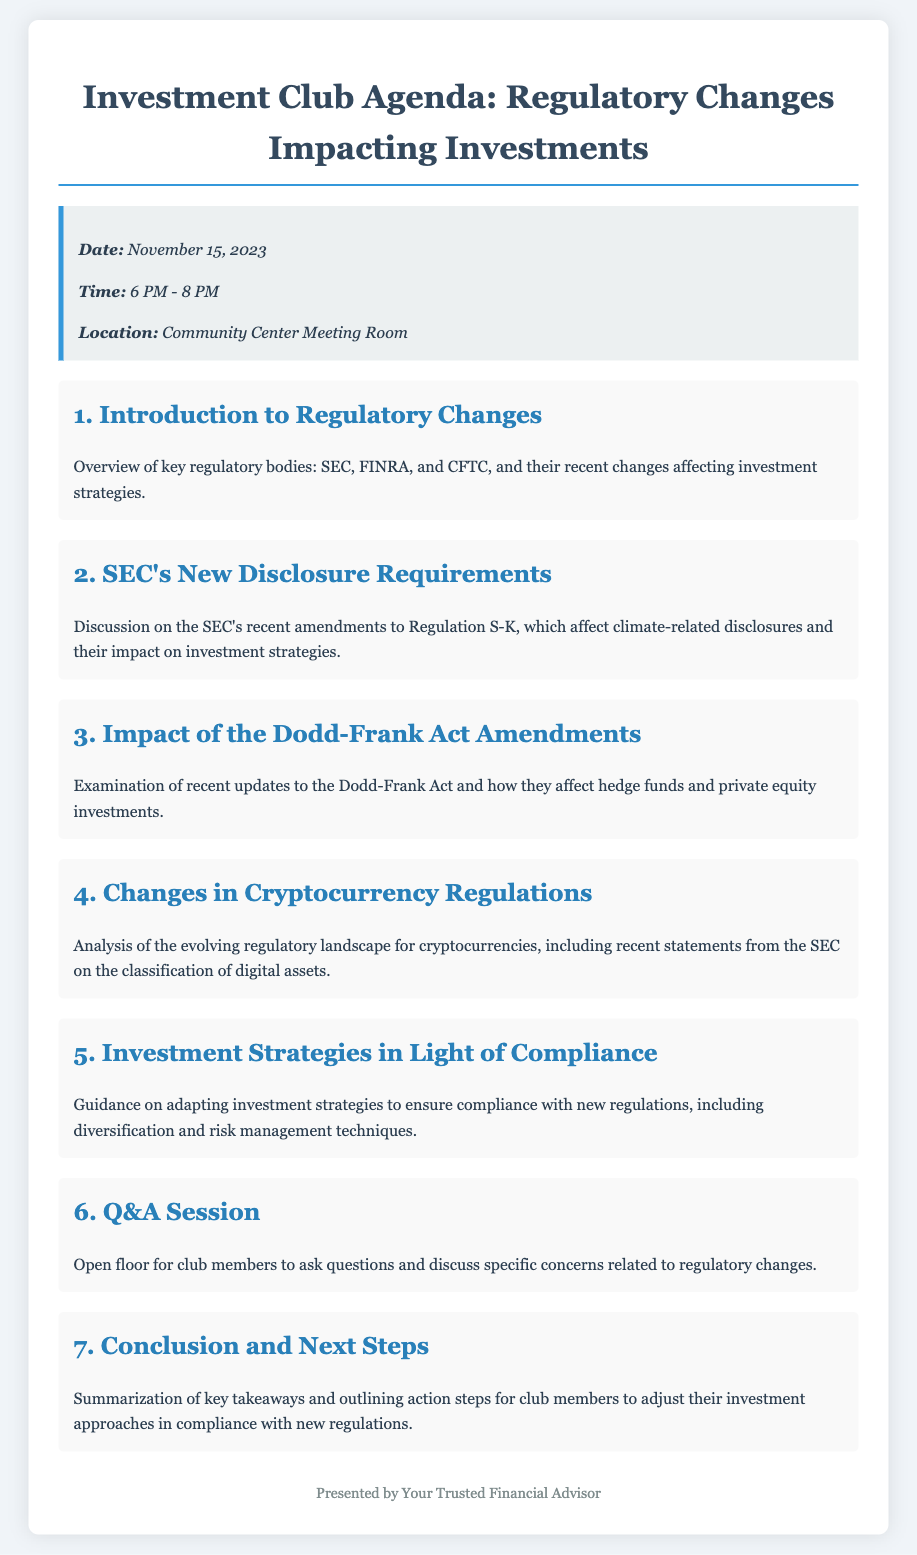What is the date of the event? The date of the event is specified in the event details section, which is November 15, 2023.
Answer: November 15, 2023 What is the time of the meeting? The time is indicated alongside the date in the event details, which is from 6 PM to 8 PM.
Answer: 6 PM - 8 PM Who are the key regulatory bodies mentioned? The agenda introduces three key regulatory bodies affecting investment strategies, which are the SEC, FINRA, and CFTC.
Answer: SEC, FINRA, CFTC What does the SEC's recent amendment affect? The description of the SEC's new disclosure requirements notes that the amendment concerns climate-related disclosures.
Answer: Climate-related disclosures Which act's amendments are discussed in the agenda? The agenda specifically mentions the Dodd-Frank Act and its recent updates affecting hedge funds and private equity.
Answer: Dodd-Frank Act What is one strategy suggested for compliance? The agenda item on adapting investment strategies mentions that diversification can be a strategy for compliance with new regulations.
Answer: Diversification How many main agenda items are listed? The total number of agenda items listed in the document adds up to seven significant topics for discussion.
Answer: Seven What session allows for member questions? The Q&A session section provides an opportunity for club members to ask questions and discuss regulatory concerns.
Answer: Q&A Session 